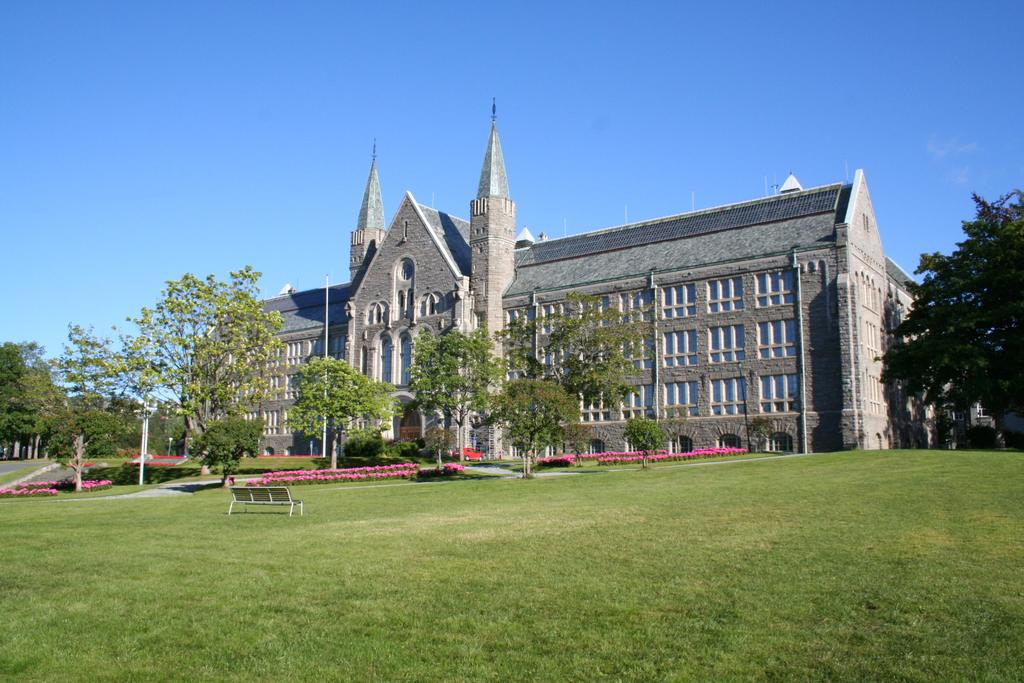What is the main subject in the middle of the image? There is a very big building in the middle of the image. What type of vegetation can be seen in the image? There are trees in the image. What type of ground cover is present on the downside of the image? There is grass on the downside of the image. Is there a toothbrush hidden in the grass in the image? There is no toothbrush present in the image. 